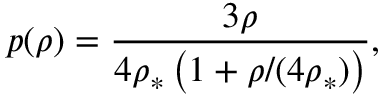<formula> <loc_0><loc_0><loc_500><loc_500>p ( \rho ) = \frac { 3 \rho } { 4 \rho _ { \ast } \left ( 1 + \rho / ( 4 \rho _ { \ast } ) \right ) } ,</formula> 